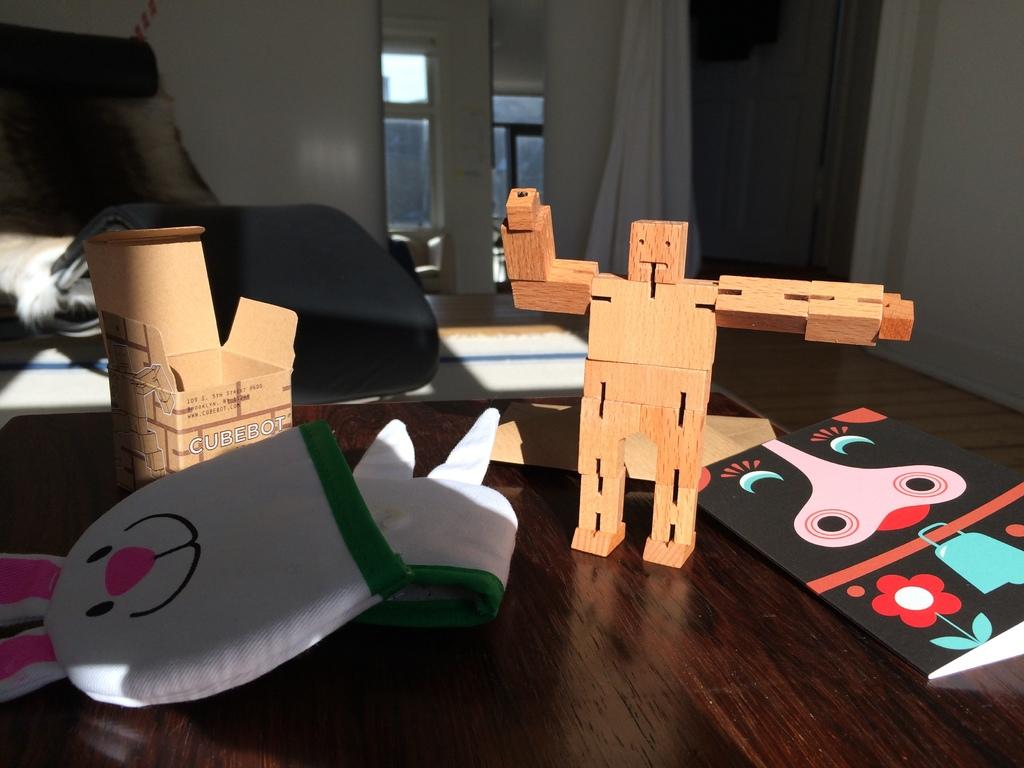What kind of bots are these?
Keep it short and to the point. Cubebot. Are those robots?
Offer a terse response. Answering does not require reading text in the image. 